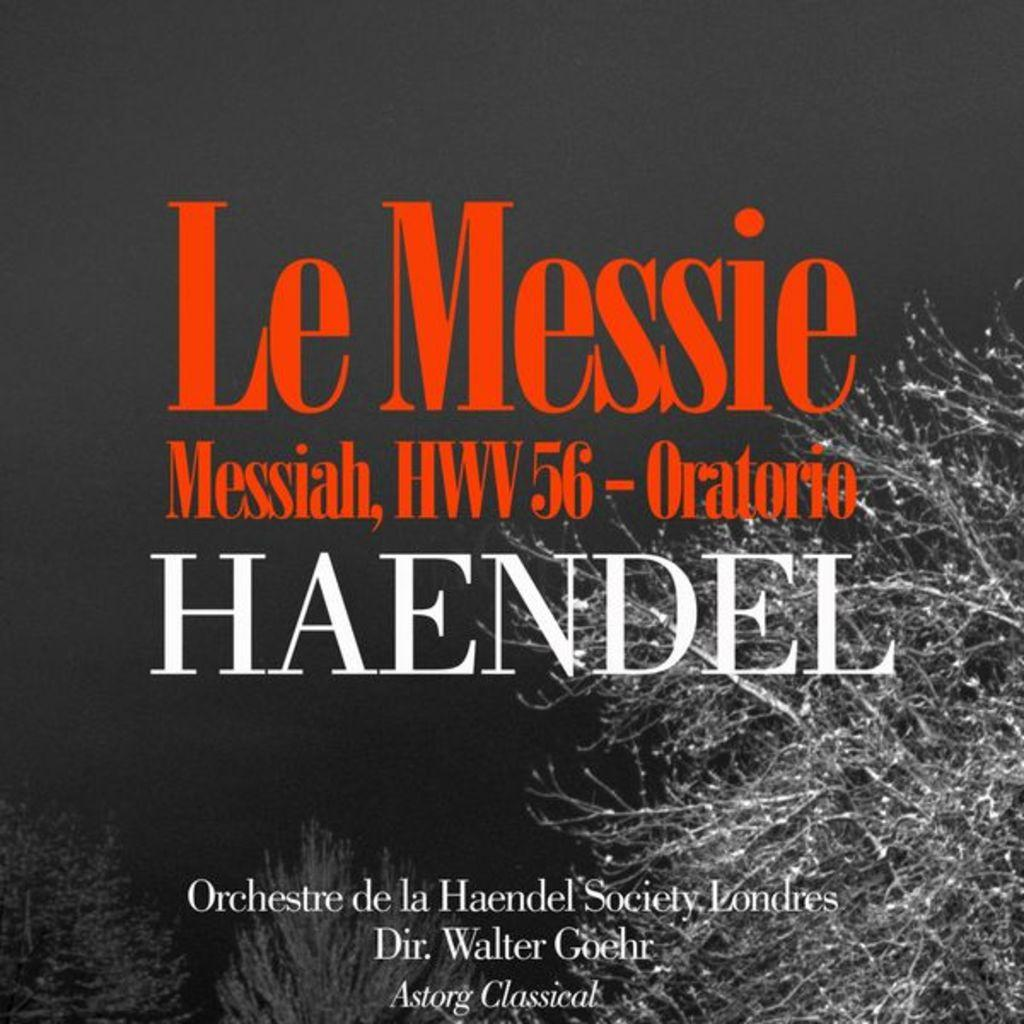<image>
Present a compact description of the photo's key features. A flyer shows Le Messie Messiah by Haendel on it. 